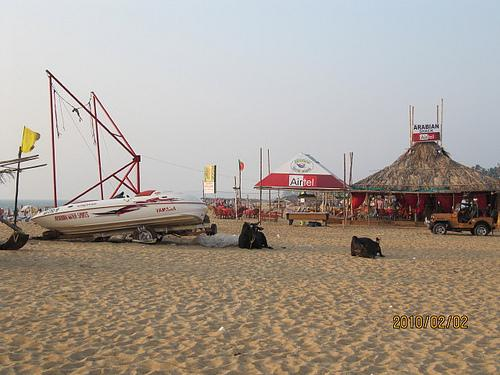What type of geographical feature is located near this area? Please explain your reasoning. ocean. When we think of a beach, we almost automatically think of the water nearby. 